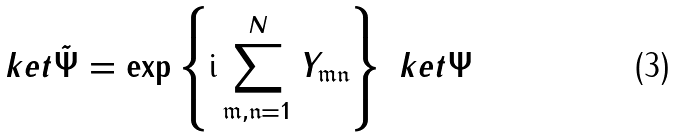<formula> <loc_0><loc_0><loc_500><loc_500>\ k e t { \tilde { \Psi } } = \exp \left \{ \text {i} \sum _ { \mathfrak { m , n } = 1 } ^ { N } Y _ { \mathfrak { m n } } \right \} \ k e t { \Psi }</formula> 